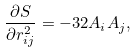Convert formula to latex. <formula><loc_0><loc_0><loc_500><loc_500>\frac { \partial S } { \partial r _ { i j } ^ { 2 } } = - 3 2 A _ { i } A _ { j } ,</formula> 